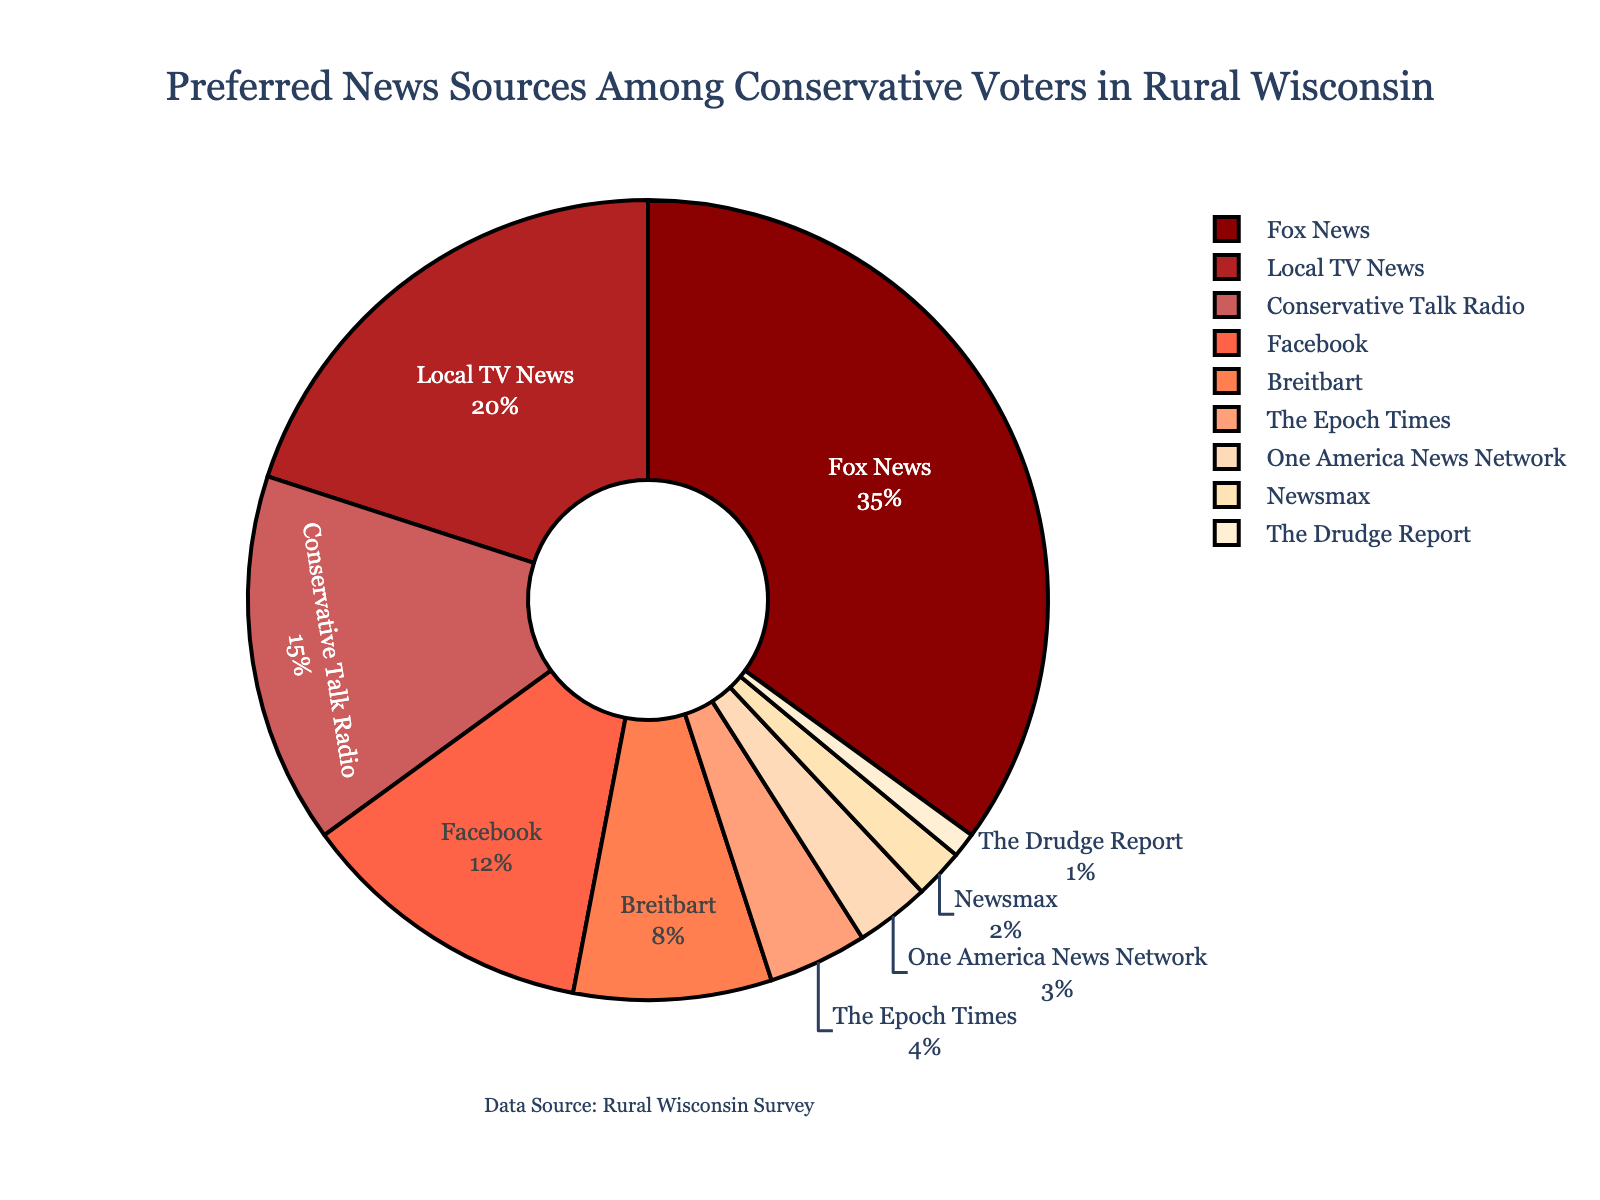Which news source is the most preferred among conservative voters in rural Wisconsin? The largest segment in the pie chart, represented in red color, is labeled as "Fox News" with a percentage of 35%.
Answer: Fox News What is the combined percentage of local TV news and conservative talk radio? Identify the segments labeled as "Local TV News" (20%) and "Conservative Talk Radio" (15%). Add these two percentages together: 20% + 15% = 35%.
Answer: 35% Which news sources have less than 10% preference among voters? Segments labeled with "Breitbart" (8%), "The Epoch Times" (4%), "One America News Network" (3%), "Newsmax" (2%), and "The Drudge Report" (1%) each have less than 10% preference.
Answer: Breitbart, The Epoch Times, One America News Network, Newsmax, The Drudge Report How does the preference for Breitbart compare to the preference for Facebook? Locate the segments labeled "Breitbart" (8%) and "Facebook" (12%). Facebook's preference (12%) is greater than Breitbart's preference (8%).
Answer: Facebook is preferred more than Breitbart What is the visual difference in terms of color between the most and least preferred news sources? The most preferred new source is "Fox News" (35%) in red, and the least preferred is "The Drudge Report" (1%) in cream.
Answer: Red (Fox News) vs. Cream (The Drudge Report) What is the total percentage for news sources that are preferred by more than 10% of voters each? Segments with more than 10% preference are "Fox News" (35%), "Local TV News" (20%), and "Conservative Talk Radio" (15%). Sum these percentages: 35% + 20% + 15% = 70%.
Answer: 70% Are there more voters preferring local TV news or conservative talk radio? Compare segments labeled "Local TV News" (20%) and "Conservative Talk Radio" (15%). Local TV News has a higher percentage (20%) compared to Conservative Talk Radio (15%).
Answer: Local TV News What percentage of voters prefer news sources other than the top three preferred sources? The top three preferred sources are "Fox News" (35%), "Local TV News" (20%), and "Conservative Talk Radio" (15%). Combine these percentages: 35% + 20% + 15% = 70%. Subtract this from 100%: 100% - 70% = 30%.
Answer: 30% By how much is Facebook's preference percentage greater than The Epoch Times' preference percentage? Locate the segments labeled "Facebook" (12%) and "The Epoch Times" (4%). Subtract The Epoch Times' percentage from Facebook's: 12% - 4% = 8%.
Answer: 8% What visual cue indicates the second most preferred news source? The segment representing the second most preferred news source is "Local TV News" with 20%. It is visually identified by its size and position relative to "Fox News."
Answer: Local TV News (20%) 